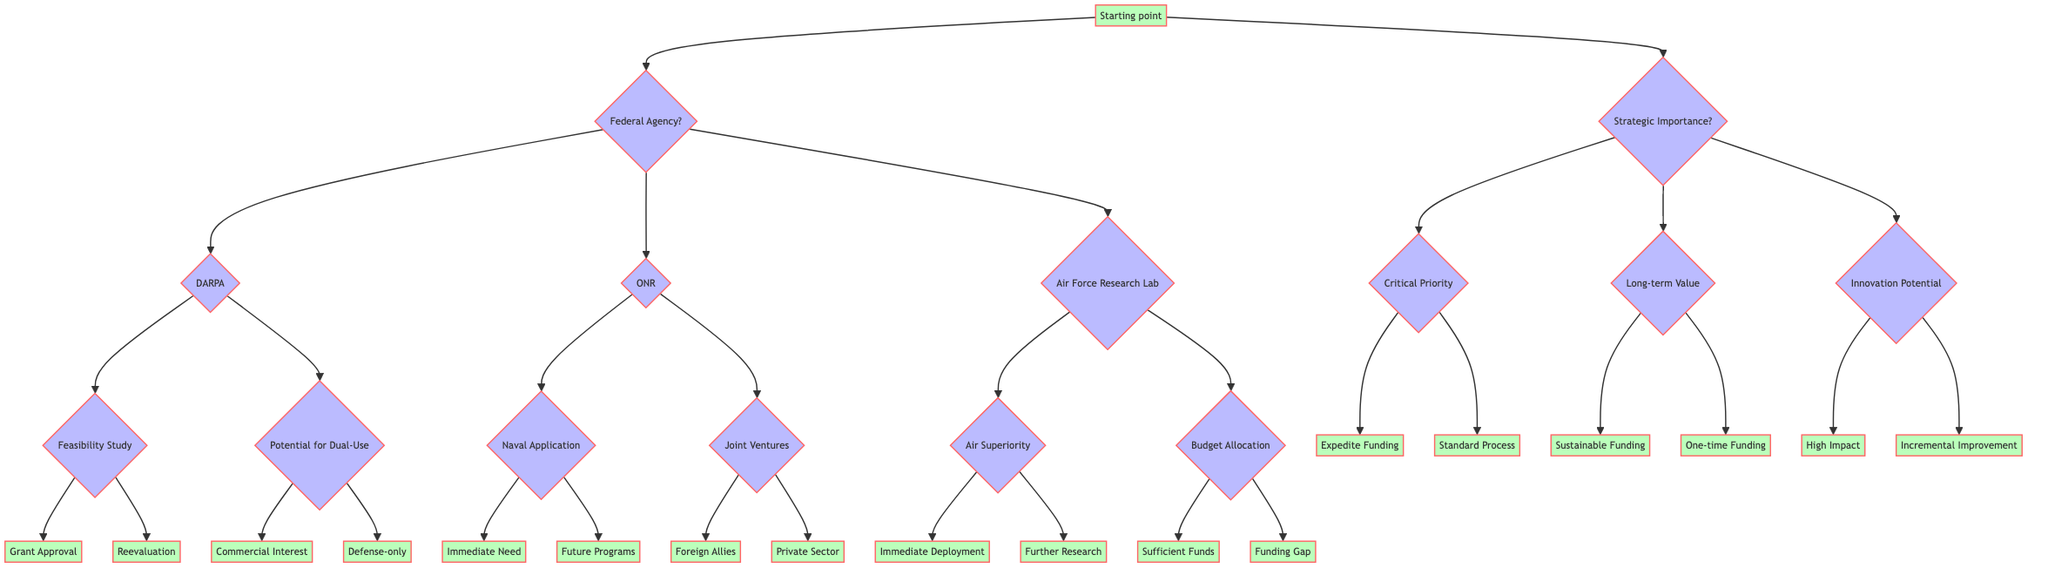What is the starting point for determining pathways for new military technology research grants? The diagram indicates that the starting point is the node labeled "Starting point," which outlines the two main branches for decision-making—Federal Agency and Strategic Importance.
Answer: Starting point How many federal agencies are listed in the diagram? The diagram presents three federal agencies: DARPA, ONR, and Air Force Research Laboratory. These agencies are represented as choices branching from the "Federal Agency" node.
Answer: 3 What will the next step be if the technology has dual-use potential? From the "Potential for Dual-Use" node, if the technology is identified to have dual-use potential, the next choices involve assessing either "Commercial Interest" or "Defense-only," based on the flow of the diagram.
Answer: Commercial Interest or Defense-only Is the feasibility study completed? The "Feasibility Study" node branches into two subsequent outcomes: "Grant Approval" if completed, or "Need for reevaluation" if further feasibility testing is required. Thus, this question checks the status of the feasibility study.
Answer: Yes or No What happens if the technology is a critical priority for national security? If the technology is assessed as a "Critical Priority," the flow leads to two potential outcomes: "Expedite Funding" due to its status or to follow the "Standard Process" for grant approval, allowing the decision to be expedited.
Answer: Expedite Funding or Standard Process What option follows if there is a funding gap for the technology project? Upon assessing "Budget Allocation," if there is a "Funding Gap," this indicates the need for addressing funding issues before proceeding; however, this decision may not lead directly to an outcome unless further choices are considered.
Answer: Funding Gap How does immediate operational need affect naval applications? If the naval application is determined to have "Immediate Need," this implies that it necessitates urgent funding and support. The diagram indicates this directly leads to a favorable outcome for that technology project.
Answer: Immediate Need What does high innovation potential indicate for technology? Assessing "Innovation Potential," if the technology is categorized as "High Impact," it is viewed as transformative, which can lead to more favorable funding outcomes and prioritization in military technology initiatives.
Answer: High Impact 